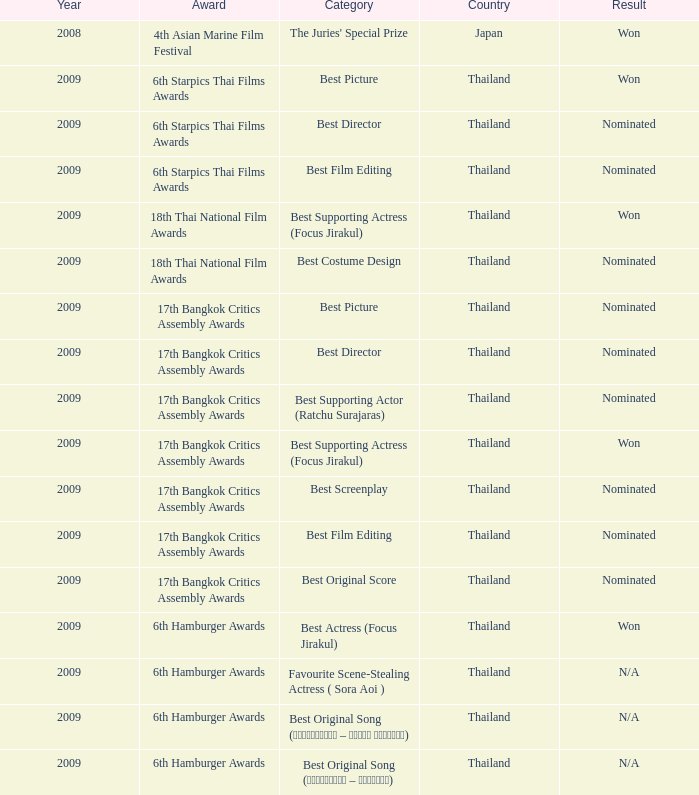In what year did the 17th bangkok critics assembly awards occur, including a category for best original score? 2009.0. 